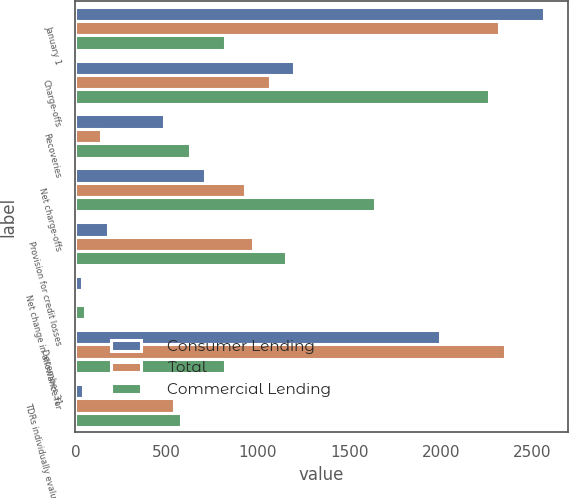Convert chart. <chart><loc_0><loc_0><loc_500><loc_500><stacked_bar_chart><ecel><fcel>January 1<fcel>Charge-offs<fcel>Recoveries<fcel>Net charge-offs<fcel>Provision for credit losses<fcel>Net change in allowance for<fcel>December 31<fcel>TDRs individually evaluated<nl><fcel>Consumer Lending<fcel>2567<fcel>1199<fcel>487<fcel>712<fcel>177<fcel>36<fcel>1995<fcel>39<nl><fcel>Total<fcel>2320<fcel>1065<fcel>138<fcel>927<fcel>975<fcel>16<fcel>2352<fcel>541<nl><fcel>Commercial Lending<fcel>819.5<fcel>2264<fcel>625<fcel>1639<fcel>1152<fcel>52<fcel>819.5<fcel>580<nl></chart> 